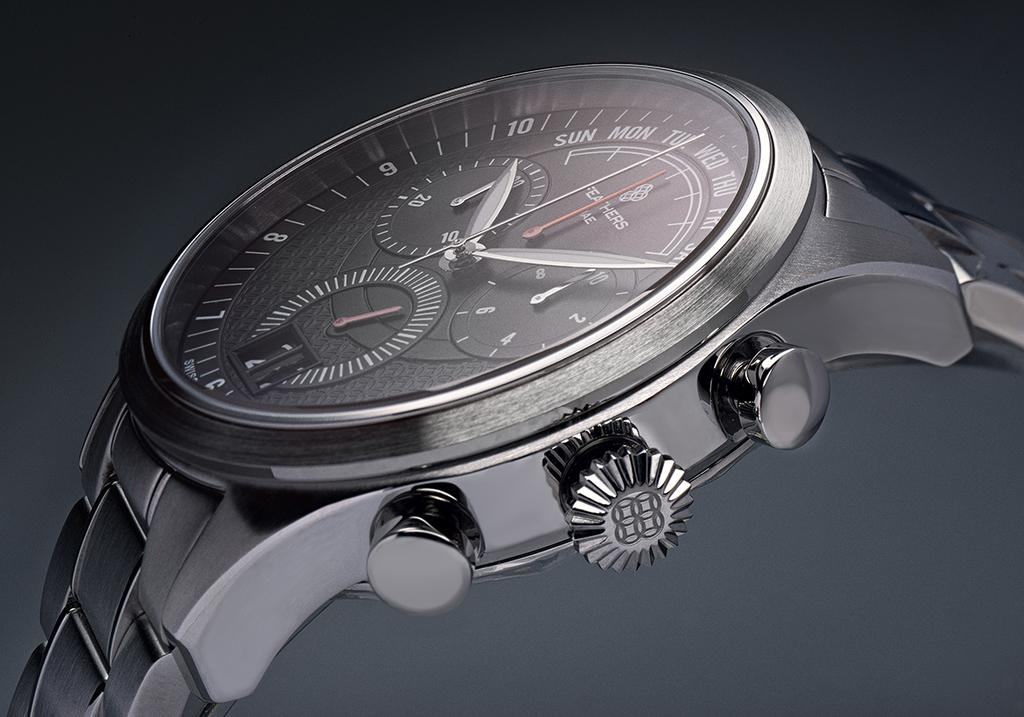<image>
Give a short and clear explanation of the subsequent image. the feathers watch has the days of the week on the face 